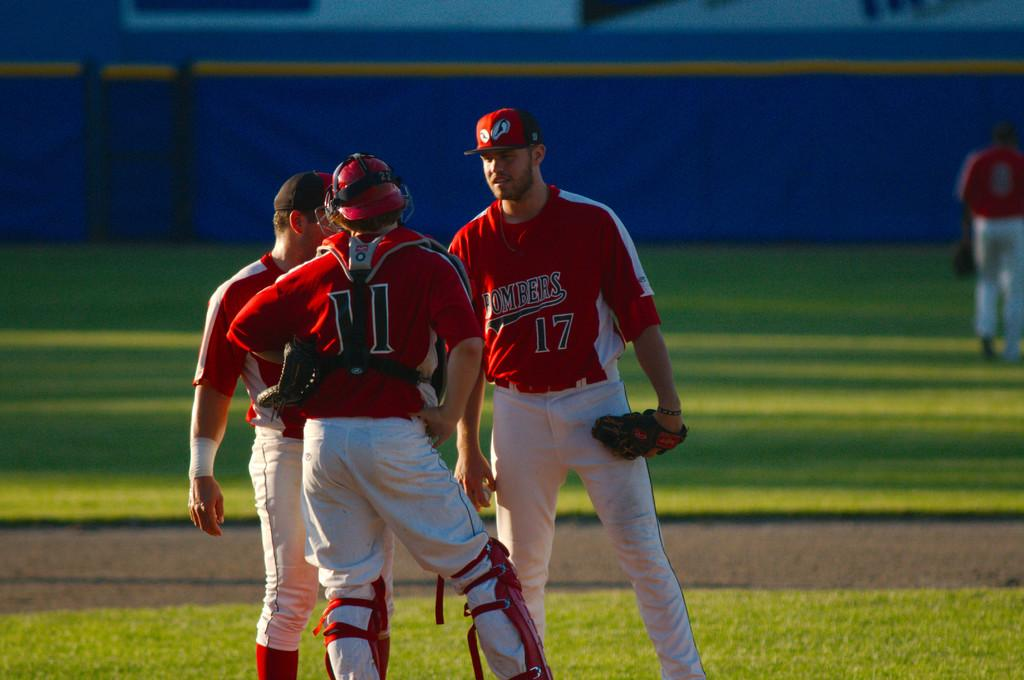Provide a one-sentence caption for the provided image. A baseball player has the number 11 on the back of his shirt. 